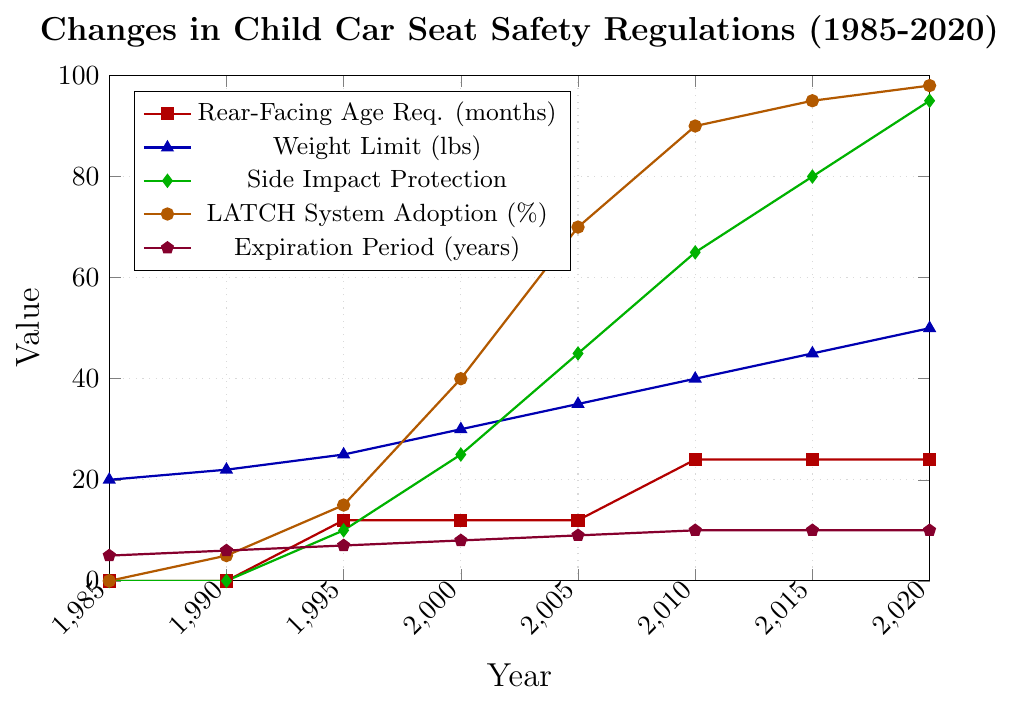What is the rear-facing age requirement in months for child car seats in 2020? The rear-facing age requirement in 2020 can be determined by looking at the red line representing this metric. The label on the line shows that it is at 24 months.
Answer: 24 months Which year had the highest weight limit for child car seats? To find the highest weight limit, look for the peak value of the blue line. The highest point is at 2020 with a weight limit of 50 lbs.
Answer: 2020 How has the LATCH system adoption percentage changed from 1985 to 2020? To understand this, look at the orange line from 1985 to 2020. In 1985, LATCH system adoption was 0%, and it increased to 98% in 2020.
Answer: Improved by 98% Compare the side impact protection in 1995 and 2010. Locate the green line for these years. In 1995, the side impact protection was at 10, and by 2010, it had increased to 65.
Answer: Increased by 55 What was the expiration period for child car seats in 2000? Refer to the purple line at the year 2000, and the label indicates the expiration period to be at 8 years.
Answer: 8 years What is the difference in rear-facing age requirement between 1995 and 2010? Compare the red line values for these years. In 1995, it was 12 months, and in 2010, it was 24 months. The difference is 24 - 12.
Answer: 12 months Which safety metric shows the most significant change from 1985 to 2020? Examine the visual changes across all colored lines from 1985 to 2020. The green line (Side Impact Protection) shows the most significant change from 0 to 95 units.
Answer: Side Impact Protection What was the weight limit for child car seats in 2005? The weight limit in 2005 can be found by looking at the blue line for that year, which shows the weight as 35 lbs.
Answer: 35 lbs What is the average expiration period from 1990 to 2020? The values from the purple line for each of these years are: 6, 7, 8, 9, 10, 10, and 10. The average is (6+7+8+9+10+10+10)/7.
Answer: 8.57 years Which color represents the LATCH system adoption metric, and how can you identify it in the chart? The orange line represents the LATCH system adoption metric. It can be identified by its color and the circular markers used along the line, and the legend that matches the color.
Answer: Orange 